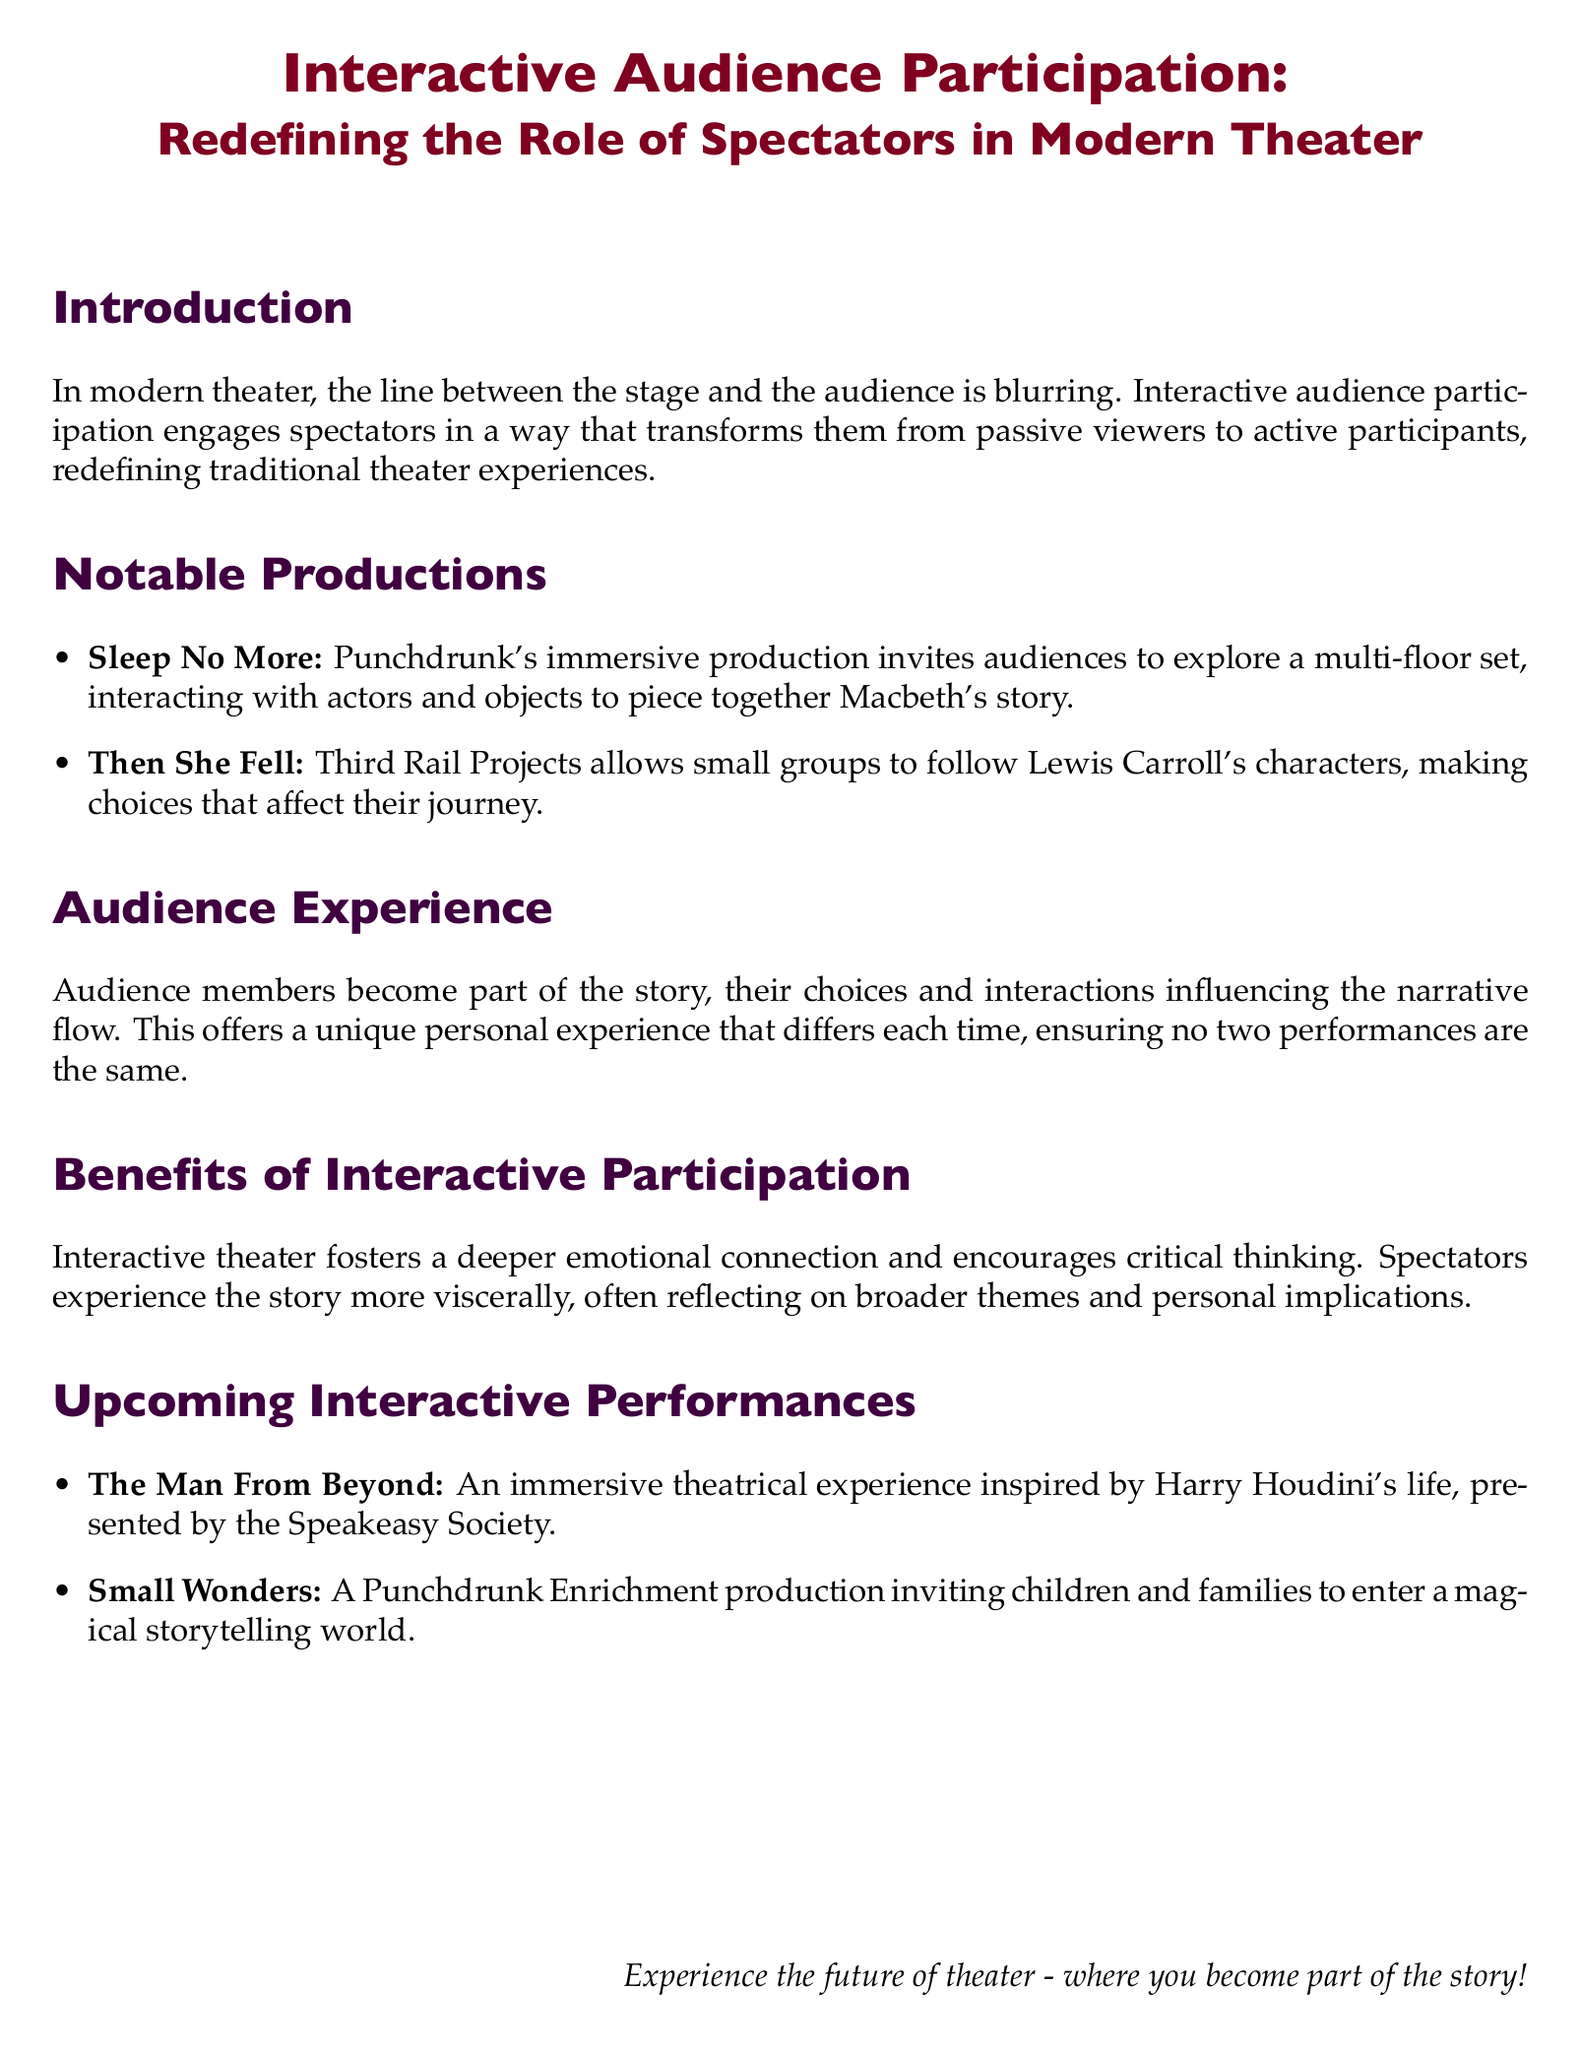What is the title of the Playbill? The title is prominently displayed at the top, stating the theme of the performance.
Answer: Interactive Audience Participation: Redefining the Role of Spectators in Modern Theater Who is the production company behind "Sleep No More"? The document specifies the company that created this immersive production.
Answer: Punchdrunk What type of experience does "Then She Fell" offer? The document describes the nature of the audience's involvement in this production.
Answer: Small group following characters What is a benefit of interactive theater mentioned in the document? The document lists specific advantages of this type of performance.
Answer: Deeper emotional connection Which character's journey is explored in "Then She Fell"? The document highlights the literary figure that the production is based on.
Answer: Lewis Carroll How does audience participation influence the narrative flow? The document explains the impact of audience choices on the story being told.
Answer: Influencing narrative flow What is the name of the upcoming performance inspired by Harry Houdini? The document provides the title of one of the upcoming interactive performances.
Answer: The Man From Beyond What is the focus of the Punchdrunk Enrichment production mentioned? The document describes the target audience for this specific performance.
Answer: Children and families 